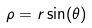Convert formula to latex. <formula><loc_0><loc_0><loc_500><loc_500>\rho = r \sin ( \theta )</formula> 